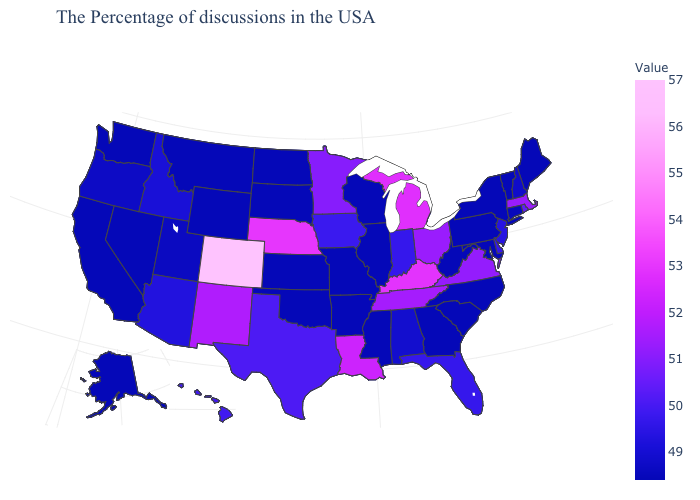Among the states that border Maryland , which have the lowest value?
Give a very brief answer. Pennsylvania, West Virginia. Does South Dakota have the lowest value in the USA?
Concise answer only. Yes. 